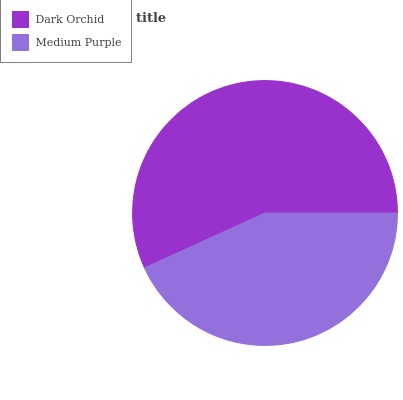Is Medium Purple the minimum?
Answer yes or no. Yes. Is Dark Orchid the maximum?
Answer yes or no. Yes. Is Medium Purple the maximum?
Answer yes or no. No. Is Dark Orchid greater than Medium Purple?
Answer yes or no. Yes. Is Medium Purple less than Dark Orchid?
Answer yes or no. Yes. Is Medium Purple greater than Dark Orchid?
Answer yes or no. No. Is Dark Orchid less than Medium Purple?
Answer yes or no. No. Is Dark Orchid the high median?
Answer yes or no. Yes. Is Medium Purple the low median?
Answer yes or no. Yes. Is Medium Purple the high median?
Answer yes or no. No. Is Dark Orchid the low median?
Answer yes or no. No. 